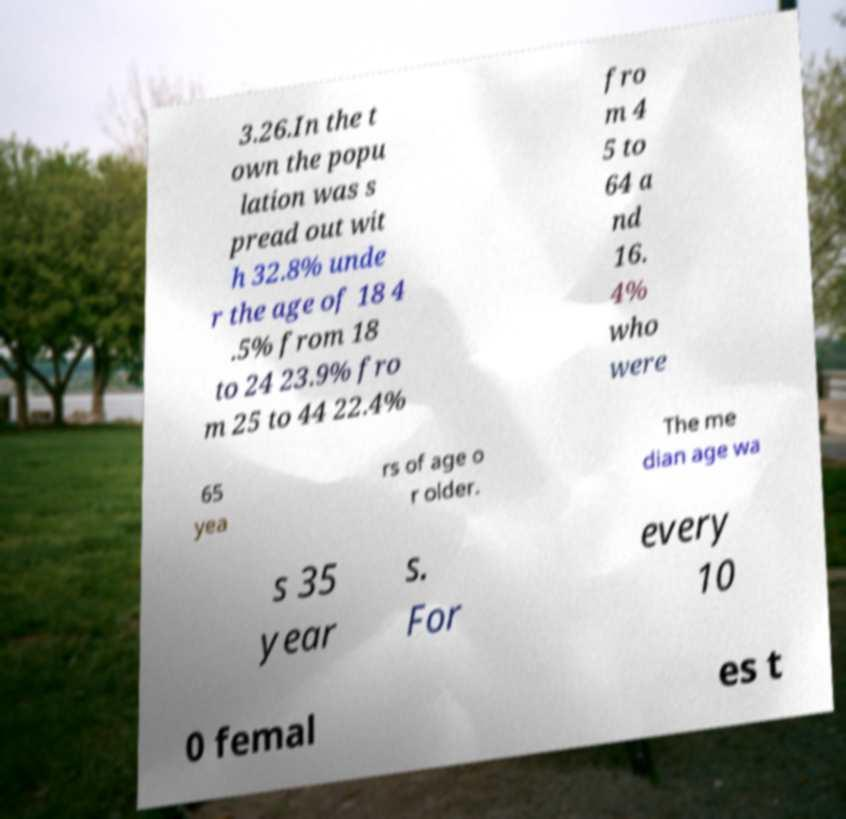For documentation purposes, I need the text within this image transcribed. Could you provide that? 3.26.In the t own the popu lation was s pread out wit h 32.8% unde r the age of 18 4 .5% from 18 to 24 23.9% fro m 25 to 44 22.4% fro m 4 5 to 64 a nd 16. 4% who were 65 yea rs of age o r older. The me dian age wa s 35 year s. For every 10 0 femal es t 